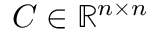Convert formula to latex. <formula><loc_0><loc_0><loc_500><loc_500>C \in \mathbb { R } ^ { n \times n }</formula> 